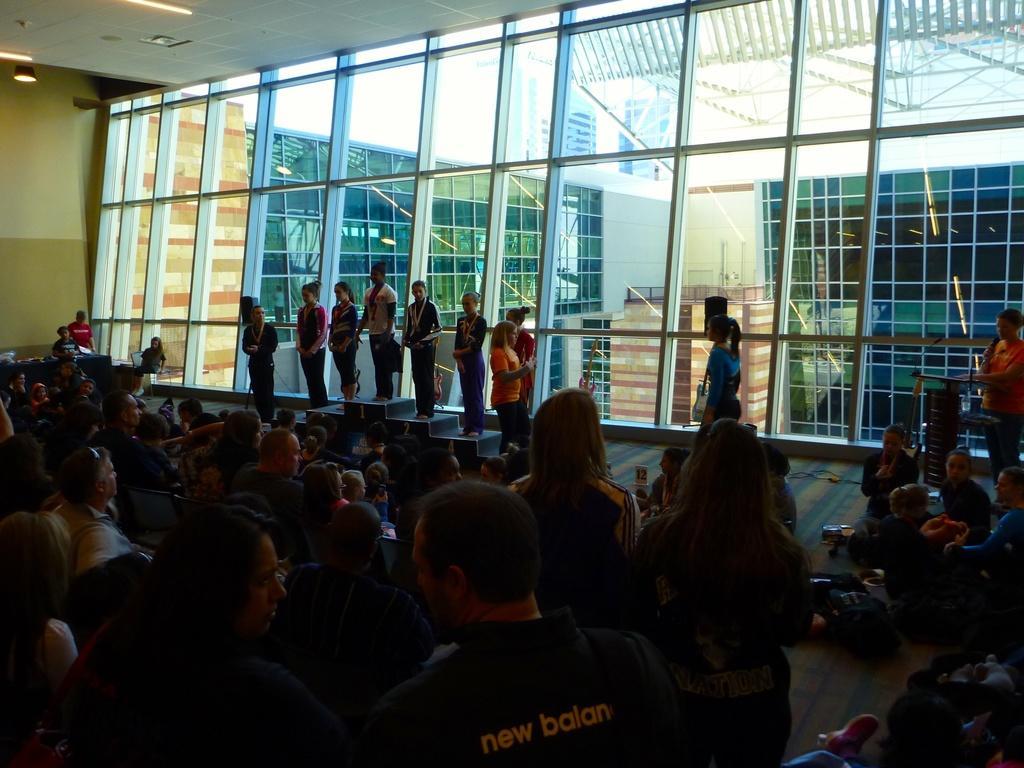Can you describe this image briefly? In this picture we can see a group of people where some are standing and some are sitting on chairs and some are sitting on the floor and some are standing on a podium and a person holding a mic and standing at the podium and some objects and in the background we can see the lights, walls, buildings. 